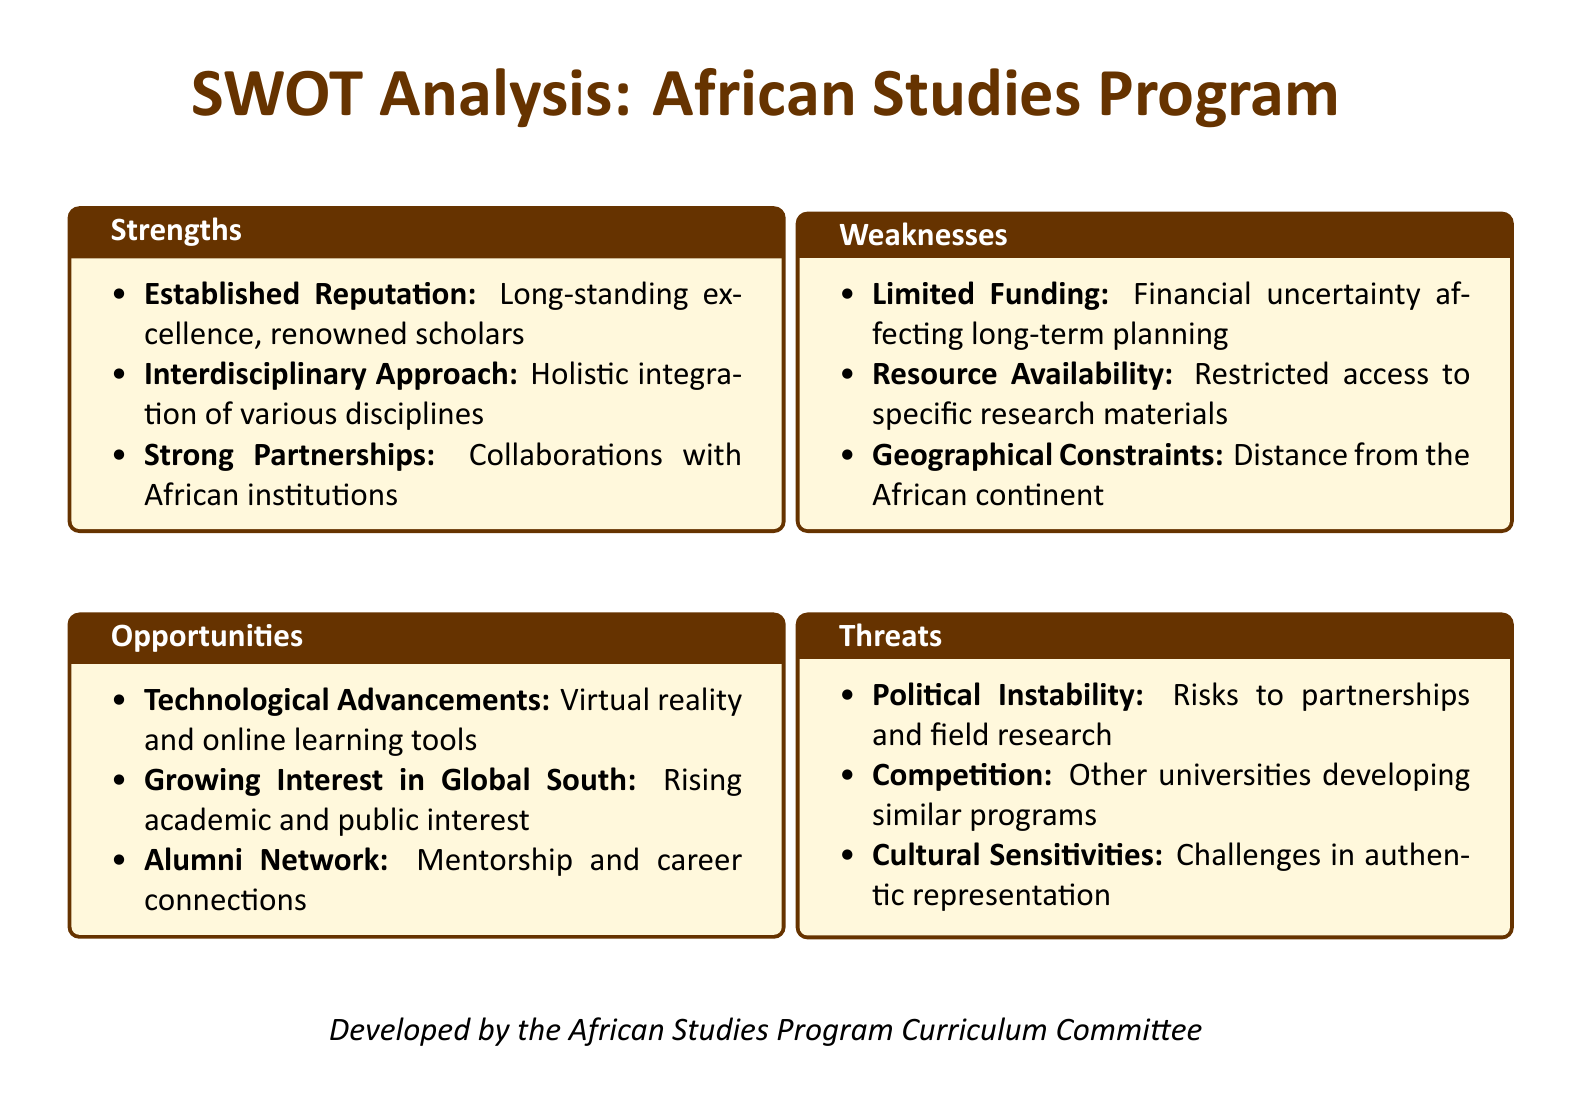What is the title of the document? The title is presented at the center of the document as "SWOT Analysis: African Studies Program."
Answer: SWOT Analysis: African Studies Program How many strengths are listed in the document? There are three strengths enumerated under the Strengths section, which can be counted from the list.
Answer: 3 What is one of the opportunities mentioned? The document lists several opportunities, and one can be directly taken from the Opportunities section.
Answer: Technological Advancements What financial issue is noted as a weakness? The document specifically mentions a financial issue affecting the program in the Weaknesses section.
Answer: Limited Funding Which entity developed this document? The last line of the document identifies the group responsible for its development.
Answer: African Studies Program Curriculum Committee What is one threat mentioned in the analysis? A threat listed under the Threats section can be directly referenced here.
Answer: Political Instability What type of approach is highlighted as a strength? The document specifies the nature of the program's academic approach under the Strengths section.
Answer: Interdisciplinary Approach What is a reason for the growing interest mentioned in the Opportunities section? The document provides a specific reason for the increased interest in the program.
Answer: Rising academic and public interest 